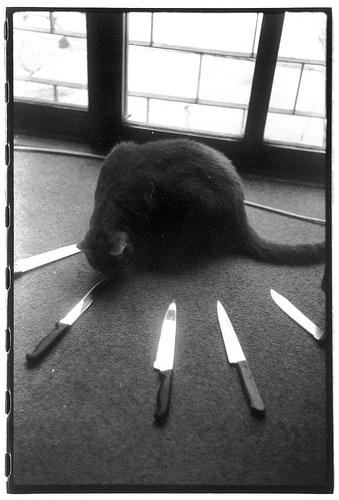What is the cat near? Please explain your reasoning. knives. The kitty is on the floor with many cutting tools around him. 